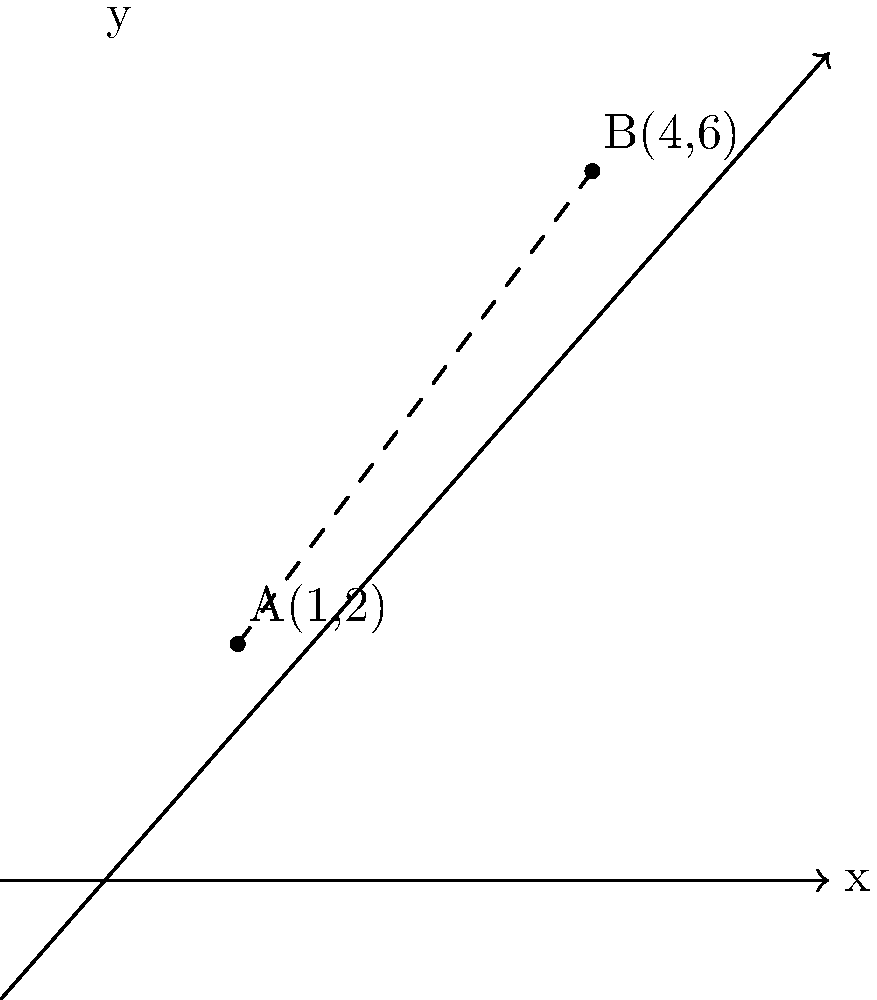As a data analyst working with car performance data, you need to calculate the distance between two cars on a coordinate plane. Car A is located at point (1,2) and Car B is at point (4,6). What is the distance between these two cars? To calculate the distance between two points on a coordinate plane, we can use the distance formula, which is derived from the Pythagorean theorem:

$$ d = \sqrt{(x_2 - x_1)^2 + (y_2 - y_1)^2} $$

Where $(x_1, y_1)$ are the coordinates of the first point and $(x_2, y_2)$ are the coordinates of the second point.

Let's plug in our values:
- Car A: $(x_1, y_1) = (1, 2)$
- Car B: $(x_2, y_2) = (4, 6)$

Now, let's calculate step by step:

1) $d = \sqrt{(4 - 1)^2 + (6 - 2)^2}$

2) $d = \sqrt{3^2 + 4^2}$

3) $d = \sqrt{9 + 16}$

4) $d = \sqrt{25}$

5) $d = 5$

Therefore, the distance between Car A and Car B is 5 units.
Answer: 5 units 